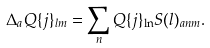<formula> <loc_0><loc_0><loc_500><loc_500>\Delta _ { a } Q \{ j \} _ { l m } = \sum _ { n } Q \{ j \} _ { \ln } S ( l ) _ { a n m } .</formula> 